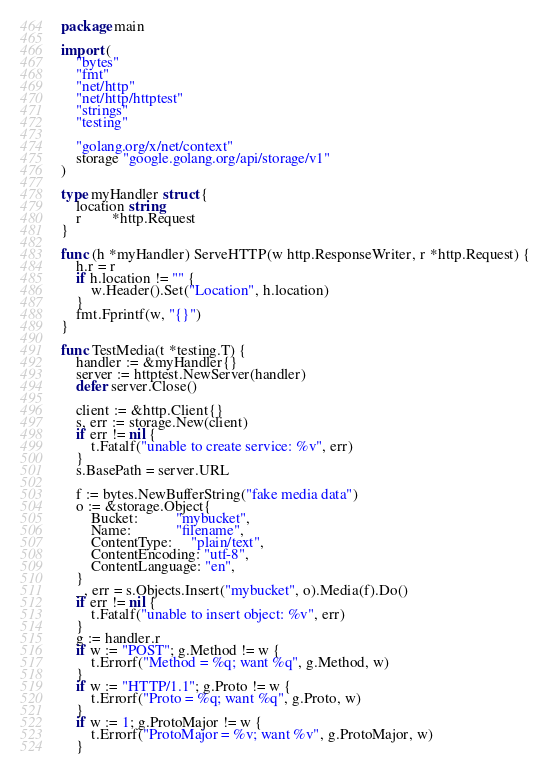<code> <loc_0><loc_0><loc_500><loc_500><_Go_>package main

import (
	"bytes"
	"fmt"
	"net/http"
	"net/http/httptest"
	"strings"
	"testing"

	"golang.org/x/net/context"
	storage "google.golang.org/api/storage/v1"
)

type myHandler struct {
	location string
	r        *http.Request
}

func (h *myHandler) ServeHTTP(w http.ResponseWriter, r *http.Request) {
	h.r = r
	if h.location != "" {
		w.Header().Set("Location", h.location)
	}
	fmt.Fprintf(w, "{}")
}

func TestMedia(t *testing.T) {
	handler := &myHandler{}
	server := httptest.NewServer(handler)
	defer server.Close()

	client := &http.Client{}
	s, err := storage.New(client)
	if err != nil {
		t.Fatalf("unable to create service: %v", err)
	}
	s.BasePath = server.URL

	f := bytes.NewBufferString("fake media data")
	o := &storage.Object{
		Bucket:          "mybucket",
		Name:            "filename",
		ContentType:     "plain/text",
		ContentEncoding: "utf-8",
		ContentLanguage: "en",
	}
	_, err = s.Objects.Insert("mybucket", o).Media(f).Do()
	if err != nil {
		t.Fatalf("unable to insert object: %v", err)
	}
	g := handler.r
	if w := "POST"; g.Method != w {
		t.Errorf("Method = %q; want %q", g.Method, w)
	}
	if w := "HTTP/1.1"; g.Proto != w {
		t.Errorf("Proto = %q; want %q", g.Proto, w)
	}
	if w := 1; g.ProtoMajor != w {
		t.Errorf("ProtoMajor = %v; want %v", g.ProtoMajor, w)
	}</code> 